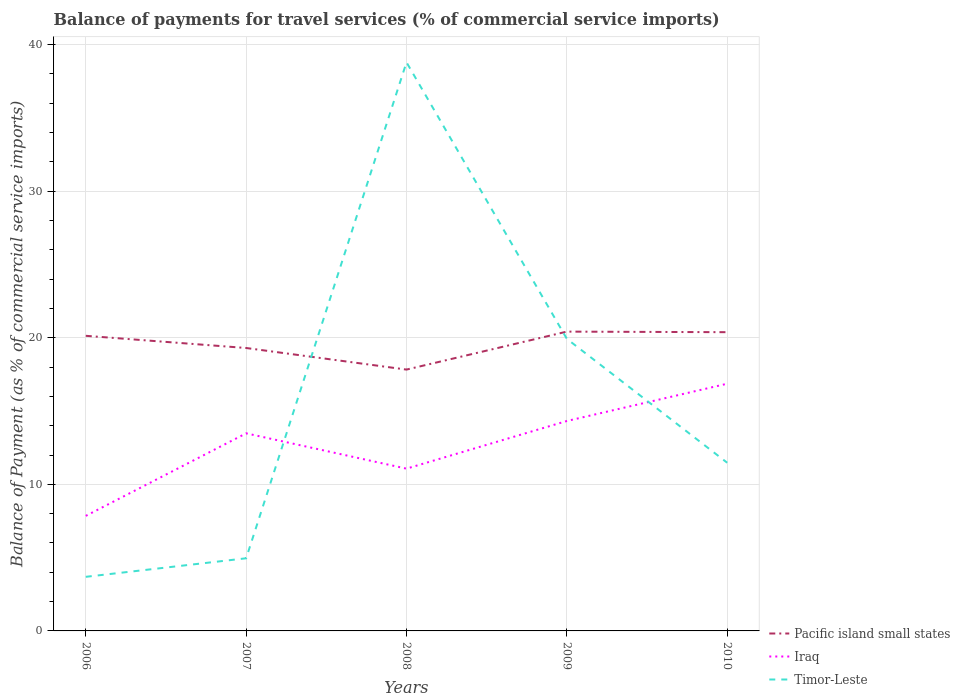Across all years, what is the maximum balance of payments for travel services in Pacific island small states?
Make the answer very short. 17.83. What is the total balance of payments for travel services in Pacific island small states in the graph?
Keep it short and to the point. 1.47. What is the difference between the highest and the second highest balance of payments for travel services in Timor-Leste?
Make the answer very short. 35.1. What is the difference between the highest and the lowest balance of payments for travel services in Timor-Leste?
Provide a short and direct response. 2. How many lines are there?
Your answer should be very brief. 3. Are the values on the major ticks of Y-axis written in scientific E-notation?
Provide a short and direct response. No. Does the graph contain any zero values?
Offer a terse response. No. Does the graph contain grids?
Make the answer very short. Yes. What is the title of the graph?
Provide a short and direct response. Balance of payments for travel services (% of commercial service imports). What is the label or title of the Y-axis?
Keep it short and to the point. Balance of Payment (as % of commercial service imports). What is the Balance of Payment (as % of commercial service imports) in Pacific island small states in 2006?
Give a very brief answer. 20.13. What is the Balance of Payment (as % of commercial service imports) in Iraq in 2006?
Your response must be concise. 7.85. What is the Balance of Payment (as % of commercial service imports) in Timor-Leste in 2006?
Provide a succinct answer. 3.69. What is the Balance of Payment (as % of commercial service imports) of Pacific island small states in 2007?
Offer a terse response. 19.3. What is the Balance of Payment (as % of commercial service imports) of Iraq in 2007?
Provide a short and direct response. 13.48. What is the Balance of Payment (as % of commercial service imports) of Timor-Leste in 2007?
Your answer should be very brief. 4.96. What is the Balance of Payment (as % of commercial service imports) of Pacific island small states in 2008?
Provide a short and direct response. 17.83. What is the Balance of Payment (as % of commercial service imports) of Iraq in 2008?
Give a very brief answer. 11.07. What is the Balance of Payment (as % of commercial service imports) in Timor-Leste in 2008?
Your response must be concise. 38.79. What is the Balance of Payment (as % of commercial service imports) of Pacific island small states in 2009?
Provide a succinct answer. 20.42. What is the Balance of Payment (as % of commercial service imports) in Iraq in 2009?
Offer a very short reply. 14.32. What is the Balance of Payment (as % of commercial service imports) in Timor-Leste in 2009?
Your answer should be compact. 19.93. What is the Balance of Payment (as % of commercial service imports) in Pacific island small states in 2010?
Keep it short and to the point. 20.38. What is the Balance of Payment (as % of commercial service imports) of Iraq in 2010?
Provide a short and direct response. 16.86. What is the Balance of Payment (as % of commercial service imports) in Timor-Leste in 2010?
Offer a very short reply. 11.47. Across all years, what is the maximum Balance of Payment (as % of commercial service imports) in Pacific island small states?
Ensure brevity in your answer.  20.42. Across all years, what is the maximum Balance of Payment (as % of commercial service imports) of Iraq?
Provide a succinct answer. 16.86. Across all years, what is the maximum Balance of Payment (as % of commercial service imports) of Timor-Leste?
Provide a succinct answer. 38.79. Across all years, what is the minimum Balance of Payment (as % of commercial service imports) in Pacific island small states?
Your answer should be compact. 17.83. Across all years, what is the minimum Balance of Payment (as % of commercial service imports) in Iraq?
Provide a short and direct response. 7.85. Across all years, what is the minimum Balance of Payment (as % of commercial service imports) in Timor-Leste?
Ensure brevity in your answer.  3.69. What is the total Balance of Payment (as % of commercial service imports) in Pacific island small states in the graph?
Your answer should be very brief. 98.06. What is the total Balance of Payment (as % of commercial service imports) in Iraq in the graph?
Your answer should be compact. 63.58. What is the total Balance of Payment (as % of commercial service imports) in Timor-Leste in the graph?
Ensure brevity in your answer.  78.84. What is the difference between the Balance of Payment (as % of commercial service imports) in Pacific island small states in 2006 and that in 2007?
Give a very brief answer. 0.83. What is the difference between the Balance of Payment (as % of commercial service imports) in Iraq in 2006 and that in 2007?
Offer a terse response. -5.63. What is the difference between the Balance of Payment (as % of commercial service imports) of Timor-Leste in 2006 and that in 2007?
Offer a very short reply. -1.26. What is the difference between the Balance of Payment (as % of commercial service imports) in Pacific island small states in 2006 and that in 2008?
Ensure brevity in your answer.  2.3. What is the difference between the Balance of Payment (as % of commercial service imports) of Iraq in 2006 and that in 2008?
Ensure brevity in your answer.  -3.22. What is the difference between the Balance of Payment (as % of commercial service imports) of Timor-Leste in 2006 and that in 2008?
Your answer should be compact. -35.1. What is the difference between the Balance of Payment (as % of commercial service imports) in Pacific island small states in 2006 and that in 2009?
Provide a short and direct response. -0.29. What is the difference between the Balance of Payment (as % of commercial service imports) of Iraq in 2006 and that in 2009?
Provide a short and direct response. -6.47. What is the difference between the Balance of Payment (as % of commercial service imports) of Timor-Leste in 2006 and that in 2009?
Ensure brevity in your answer.  -16.24. What is the difference between the Balance of Payment (as % of commercial service imports) of Pacific island small states in 2006 and that in 2010?
Give a very brief answer. -0.25. What is the difference between the Balance of Payment (as % of commercial service imports) in Iraq in 2006 and that in 2010?
Make the answer very short. -9.01. What is the difference between the Balance of Payment (as % of commercial service imports) in Timor-Leste in 2006 and that in 2010?
Give a very brief answer. -7.78. What is the difference between the Balance of Payment (as % of commercial service imports) of Pacific island small states in 2007 and that in 2008?
Ensure brevity in your answer.  1.47. What is the difference between the Balance of Payment (as % of commercial service imports) in Iraq in 2007 and that in 2008?
Your answer should be very brief. 2.41. What is the difference between the Balance of Payment (as % of commercial service imports) of Timor-Leste in 2007 and that in 2008?
Provide a short and direct response. -33.84. What is the difference between the Balance of Payment (as % of commercial service imports) in Pacific island small states in 2007 and that in 2009?
Make the answer very short. -1.12. What is the difference between the Balance of Payment (as % of commercial service imports) of Iraq in 2007 and that in 2009?
Keep it short and to the point. -0.84. What is the difference between the Balance of Payment (as % of commercial service imports) in Timor-Leste in 2007 and that in 2009?
Provide a short and direct response. -14.97. What is the difference between the Balance of Payment (as % of commercial service imports) in Pacific island small states in 2007 and that in 2010?
Offer a terse response. -1.08. What is the difference between the Balance of Payment (as % of commercial service imports) in Iraq in 2007 and that in 2010?
Provide a succinct answer. -3.38. What is the difference between the Balance of Payment (as % of commercial service imports) in Timor-Leste in 2007 and that in 2010?
Ensure brevity in your answer.  -6.52. What is the difference between the Balance of Payment (as % of commercial service imports) of Pacific island small states in 2008 and that in 2009?
Offer a very short reply. -2.59. What is the difference between the Balance of Payment (as % of commercial service imports) in Iraq in 2008 and that in 2009?
Make the answer very short. -3.25. What is the difference between the Balance of Payment (as % of commercial service imports) in Timor-Leste in 2008 and that in 2009?
Make the answer very short. 18.87. What is the difference between the Balance of Payment (as % of commercial service imports) in Pacific island small states in 2008 and that in 2010?
Give a very brief answer. -2.55. What is the difference between the Balance of Payment (as % of commercial service imports) in Iraq in 2008 and that in 2010?
Provide a succinct answer. -5.79. What is the difference between the Balance of Payment (as % of commercial service imports) in Timor-Leste in 2008 and that in 2010?
Offer a terse response. 27.32. What is the difference between the Balance of Payment (as % of commercial service imports) in Pacific island small states in 2009 and that in 2010?
Your answer should be very brief. 0.04. What is the difference between the Balance of Payment (as % of commercial service imports) in Iraq in 2009 and that in 2010?
Offer a terse response. -2.54. What is the difference between the Balance of Payment (as % of commercial service imports) in Timor-Leste in 2009 and that in 2010?
Provide a succinct answer. 8.45. What is the difference between the Balance of Payment (as % of commercial service imports) of Pacific island small states in 2006 and the Balance of Payment (as % of commercial service imports) of Iraq in 2007?
Your answer should be compact. 6.65. What is the difference between the Balance of Payment (as % of commercial service imports) of Pacific island small states in 2006 and the Balance of Payment (as % of commercial service imports) of Timor-Leste in 2007?
Your answer should be very brief. 15.18. What is the difference between the Balance of Payment (as % of commercial service imports) in Iraq in 2006 and the Balance of Payment (as % of commercial service imports) in Timor-Leste in 2007?
Your response must be concise. 2.89. What is the difference between the Balance of Payment (as % of commercial service imports) in Pacific island small states in 2006 and the Balance of Payment (as % of commercial service imports) in Iraq in 2008?
Ensure brevity in your answer.  9.06. What is the difference between the Balance of Payment (as % of commercial service imports) in Pacific island small states in 2006 and the Balance of Payment (as % of commercial service imports) in Timor-Leste in 2008?
Offer a very short reply. -18.66. What is the difference between the Balance of Payment (as % of commercial service imports) in Iraq in 2006 and the Balance of Payment (as % of commercial service imports) in Timor-Leste in 2008?
Offer a terse response. -30.94. What is the difference between the Balance of Payment (as % of commercial service imports) in Pacific island small states in 2006 and the Balance of Payment (as % of commercial service imports) in Iraq in 2009?
Your answer should be compact. 5.81. What is the difference between the Balance of Payment (as % of commercial service imports) in Pacific island small states in 2006 and the Balance of Payment (as % of commercial service imports) in Timor-Leste in 2009?
Your answer should be very brief. 0.21. What is the difference between the Balance of Payment (as % of commercial service imports) in Iraq in 2006 and the Balance of Payment (as % of commercial service imports) in Timor-Leste in 2009?
Offer a terse response. -12.08. What is the difference between the Balance of Payment (as % of commercial service imports) in Pacific island small states in 2006 and the Balance of Payment (as % of commercial service imports) in Iraq in 2010?
Keep it short and to the point. 3.27. What is the difference between the Balance of Payment (as % of commercial service imports) of Pacific island small states in 2006 and the Balance of Payment (as % of commercial service imports) of Timor-Leste in 2010?
Ensure brevity in your answer.  8.66. What is the difference between the Balance of Payment (as % of commercial service imports) in Iraq in 2006 and the Balance of Payment (as % of commercial service imports) in Timor-Leste in 2010?
Keep it short and to the point. -3.62. What is the difference between the Balance of Payment (as % of commercial service imports) of Pacific island small states in 2007 and the Balance of Payment (as % of commercial service imports) of Iraq in 2008?
Your answer should be compact. 8.23. What is the difference between the Balance of Payment (as % of commercial service imports) in Pacific island small states in 2007 and the Balance of Payment (as % of commercial service imports) in Timor-Leste in 2008?
Make the answer very short. -19.49. What is the difference between the Balance of Payment (as % of commercial service imports) in Iraq in 2007 and the Balance of Payment (as % of commercial service imports) in Timor-Leste in 2008?
Provide a succinct answer. -25.31. What is the difference between the Balance of Payment (as % of commercial service imports) of Pacific island small states in 2007 and the Balance of Payment (as % of commercial service imports) of Iraq in 2009?
Your answer should be very brief. 4.98. What is the difference between the Balance of Payment (as % of commercial service imports) of Pacific island small states in 2007 and the Balance of Payment (as % of commercial service imports) of Timor-Leste in 2009?
Make the answer very short. -0.63. What is the difference between the Balance of Payment (as % of commercial service imports) of Iraq in 2007 and the Balance of Payment (as % of commercial service imports) of Timor-Leste in 2009?
Your answer should be very brief. -6.45. What is the difference between the Balance of Payment (as % of commercial service imports) of Pacific island small states in 2007 and the Balance of Payment (as % of commercial service imports) of Iraq in 2010?
Offer a very short reply. 2.44. What is the difference between the Balance of Payment (as % of commercial service imports) in Pacific island small states in 2007 and the Balance of Payment (as % of commercial service imports) in Timor-Leste in 2010?
Your answer should be compact. 7.83. What is the difference between the Balance of Payment (as % of commercial service imports) in Iraq in 2007 and the Balance of Payment (as % of commercial service imports) in Timor-Leste in 2010?
Keep it short and to the point. 2.01. What is the difference between the Balance of Payment (as % of commercial service imports) in Pacific island small states in 2008 and the Balance of Payment (as % of commercial service imports) in Iraq in 2009?
Provide a succinct answer. 3.51. What is the difference between the Balance of Payment (as % of commercial service imports) of Pacific island small states in 2008 and the Balance of Payment (as % of commercial service imports) of Timor-Leste in 2009?
Make the answer very short. -2.1. What is the difference between the Balance of Payment (as % of commercial service imports) in Iraq in 2008 and the Balance of Payment (as % of commercial service imports) in Timor-Leste in 2009?
Offer a terse response. -8.86. What is the difference between the Balance of Payment (as % of commercial service imports) in Pacific island small states in 2008 and the Balance of Payment (as % of commercial service imports) in Iraq in 2010?
Ensure brevity in your answer.  0.96. What is the difference between the Balance of Payment (as % of commercial service imports) in Pacific island small states in 2008 and the Balance of Payment (as % of commercial service imports) in Timor-Leste in 2010?
Give a very brief answer. 6.36. What is the difference between the Balance of Payment (as % of commercial service imports) of Iraq in 2008 and the Balance of Payment (as % of commercial service imports) of Timor-Leste in 2010?
Your answer should be very brief. -0.4. What is the difference between the Balance of Payment (as % of commercial service imports) of Pacific island small states in 2009 and the Balance of Payment (as % of commercial service imports) of Iraq in 2010?
Your answer should be very brief. 3.56. What is the difference between the Balance of Payment (as % of commercial service imports) of Pacific island small states in 2009 and the Balance of Payment (as % of commercial service imports) of Timor-Leste in 2010?
Provide a short and direct response. 8.95. What is the difference between the Balance of Payment (as % of commercial service imports) in Iraq in 2009 and the Balance of Payment (as % of commercial service imports) in Timor-Leste in 2010?
Make the answer very short. 2.85. What is the average Balance of Payment (as % of commercial service imports) in Pacific island small states per year?
Provide a succinct answer. 19.61. What is the average Balance of Payment (as % of commercial service imports) of Iraq per year?
Keep it short and to the point. 12.72. What is the average Balance of Payment (as % of commercial service imports) of Timor-Leste per year?
Your answer should be very brief. 15.77. In the year 2006, what is the difference between the Balance of Payment (as % of commercial service imports) of Pacific island small states and Balance of Payment (as % of commercial service imports) of Iraq?
Offer a terse response. 12.28. In the year 2006, what is the difference between the Balance of Payment (as % of commercial service imports) of Pacific island small states and Balance of Payment (as % of commercial service imports) of Timor-Leste?
Offer a very short reply. 16.44. In the year 2006, what is the difference between the Balance of Payment (as % of commercial service imports) in Iraq and Balance of Payment (as % of commercial service imports) in Timor-Leste?
Your answer should be very brief. 4.16. In the year 2007, what is the difference between the Balance of Payment (as % of commercial service imports) in Pacific island small states and Balance of Payment (as % of commercial service imports) in Iraq?
Your answer should be compact. 5.82. In the year 2007, what is the difference between the Balance of Payment (as % of commercial service imports) in Pacific island small states and Balance of Payment (as % of commercial service imports) in Timor-Leste?
Your answer should be very brief. 14.35. In the year 2007, what is the difference between the Balance of Payment (as % of commercial service imports) of Iraq and Balance of Payment (as % of commercial service imports) of Timor-Leste?
Your answer should be very brief. 8.52. In the year 2008, what is the difference between the Balance of Payment (as % of commercial service imports) in Pacific island small states and Balance of Payment (as % of commercial service imports) in Iraq?
Provide a succinct answer. 6.76. In the year 2008, what is the difference between the Balance of Payment (as % of commercial service imports) in Pacific island small states and Balance of Payment (as % of commercial service imports) in Timor-Leste?
Provide a short and direct response. -20.96. In the year 2008, what is the difference between the Balance of Payment (as % of commercial service imports) of Iraq and Balance of Payment (as % of commercial service imports) of Timor-Leste?
Offer a terse response. -27.72. In the year 2009, what is the difference between the Balance of Payment (as % of commercial service imports) in Pacific island small states and Balance of Payment (as % of commercial service imports) in Iraq?
Ensure brevity in your answer.  6.1. In the year 2009, what is the difference between the Balance of Payment (as % of commercial service imports) of Pacific island small states and Balance of Payment (as % of commercial service imports) of Timor-Leste?
Your answer should be very brief. 0.49. In the year 2009, what is the difference between the Balance of Payment (as % of commercial service imports) of Iraq and Balance of Payment (as % of commercial service imports) of Timor-Leste?
Offer a very short reply. -5.61. In the year 2010, what is the difference between the Balance of Payment (as % of commercial service imports) in Pacific island small states and Balance of Payment (as % of commercial service imports) in Iraq?
Provide a succinct answer. 3.52. In the year 2010, what is the difference between the Balance of Payment (as % of commercial service imports) of Pacific island small states and Balance of Payment (as % of commercial service imports) of Timor-Leste?
Your answer should be compact. 8.91. In the year 2010, what is the difference between the Balance of Payment (as % of commercial service imports) in Iraq and Balance of Payment (as % of commercial service imports) in Timor-Leste?
Give a very brief answer. 5.39. What is the ratio of the Balance of Payment (as % of commercial service imports) in Pacific island small states in 2006 to that in 2007?
Keep it short and to the point. 1.04. What is the ratio of the Balance of Payment (as % of commercial service imports) in Iraq in 2006 to that in 2007?
Your response must be concise. 0.58. What is the ratio of the Balance of Payment (as % of commercial service imports) in Timor-Leste in 2006 to that in 2007?
Your answer should be compact. 0.74. What is the ratio of the Balance of Payment (as % of commercial service imports) of Pacific island small states in 2006 to that in 2008?
Make the answer very short. 1.13. What is the ratio of the Balance of Payment (as % of commercial service imports) of Iraq in 2006 to that in 2008?
Your response must be concise. 0.71. What is the ratio of the Balance of Payment (as % of commercial service imports) of Timor-Leste in 2006 to that in 2008?
Give a very brief answer. 0.1. What is the ratio of the Balance of Payment (as % of commercial service imports) of Pacific island small states in 2006 to that in 2009?
Give a very brief answer. 0.99. What is the ratio of the Balance of Payment (as % of commercial service imports) in Iraq in 2006 to that in 2009?
Your response must be concise. 0.55. What is the ratio of the Balance of Payment (as % of commercial service imports) in Timor-Leste in 2006 to that in 2009?
Your answer should be very brief. 0.19. What is the ratio of the Balance of Payment (as % of commercial service imports) in Pacific island small states in 2006 to that in 2010?
Provide a short and direct response. 0.99. What is the ratio of the Balance of Payment (as % of commercial service imports) of Iraq in 2006 to that in 2010?
Your answer should be very brief. 0.47. What is the ratio of the Balance of Payment (as % of commercial service imports) of Timor-Leste in 2006 to that in 2010?
Your response must be concise. 0.32. What is the ratio of the Balance of Payment (as % of commercial service imports) of Pacific island small states in 2007 to that in 2008?
Your response must be concise. 1.08. What is the ratio of the Balance of Payment (as % of commercial service imports) of Iraq in 2007 to that in 2008?
Your response must be concise. 1.22. What is the ratio of the Balance of Payment (as % of commercial service imports) in Timor-Leste in 2007 to that in 2008?
Provide a succinct answer. 0.13. What is the ratio of the Balance of Payment (as % of commercial service imports) in Pacific island small states in 2007 to that in 2009?
Your answer should be very brief. 0.95. What is the ratio of the Balance of Payment (as % of commercial service imports) in Iraq in 2007 to that in 2009?
Ensure brevity in your answer.  0.94. What is the ratio of the Balance of Payment (as % of commercial service imports) of Timor-Leste in 2007 to that in 2009?
Offer a terse response. 0.25. What is the ratio of the Balance of Payment (as % of commercial service imports) in Pacific island small states in 2007 to that in 2010?
Make the answer very short. 0.95. What is the ratio of the Balance of Payment (as % of commercial service imports) of Iraq in 2007 to that in 2010?
Make the answer very short. 0.8. What is the ratio of the Balance of Payment (as % of commercial service imports) in Timor-Leste in 2007 to that in 2010?
Ensure brevity in your answer.  0.43. What is the ratio of the Balance of Payment (as % of commercial service imports) in Pacific island small states in 2008 to that in 2009?
Offer a terse response. 0.87. What is the ratio of the Balance of Payment (as % of commercial service imports) of Iraq in 2008 to that in 2009?
Offer a very short reply. 0.77. What is the ratio of the Balance of Payment (as % of commercial service imports) in Timor-Leste in 2008 to that in 2009?
Your answer should be compact. 1.95. What is the ratio of the Balance of Payment (as % of commercial service imports) of Pacific island small states in 2008 to that in 2010?
Your answer should be compact. 0.87. What is the ratio of the Balance of Payment (as % of commercial service imports) in Iraq in 2008 to that in 2010?
Make the answer very short. 0.66. What is the ratio of the Balance of Payment (as % of commercial service imports) of Timor-Leste in 2008 to that in 2010?
Ensure brevity in your answer.  3.38. What is the ratio of the Balance of Payment (as % of commercial service imports) of Pacific island small states in 2009 to that in 2010?
Provide a succinct answer. 1. What is the ratio of the Balance of Payment (as % of commercial service imports) of Iraq in 2009 to that in 2010?
Your response must be concise. 0.85. What is the ratio of the Balance of Payment (as % of commercial service imports) of Timor-Leste in 2009 to that in 2010?
Your response must be concise. 1.74. What is the difference between the highest and the second highest Balance of Payment (as % of commercial service imports) of Pacific island small states?
Your answer should be very brief. 0.04. What is the difference between the highest and the second highest Balance of Payment (as % of commercial service imports) of Iraq?
Your answer should be very brief. 2.54. What is the difference between the highest and the second highest Balance of Payment (as % of commercial service imports) of Timor-Leste?
Give a very brief answer. 18.87. What is the difference between the highest and the lowest Balance of Payment (as % of commercial service imports) of Pacific island small states?
Make the answer very short. 2.59. What is the difference between the highest and the lowest Balance of Payment (as % of commercial service imports) of Iraq?
Offer a terse response. 9.01. What is the difference between the highest and the lowest Balance of Payment (as % of commercial service imports) in Timor-Leste?
Your answer should be very brief. 35.1. 